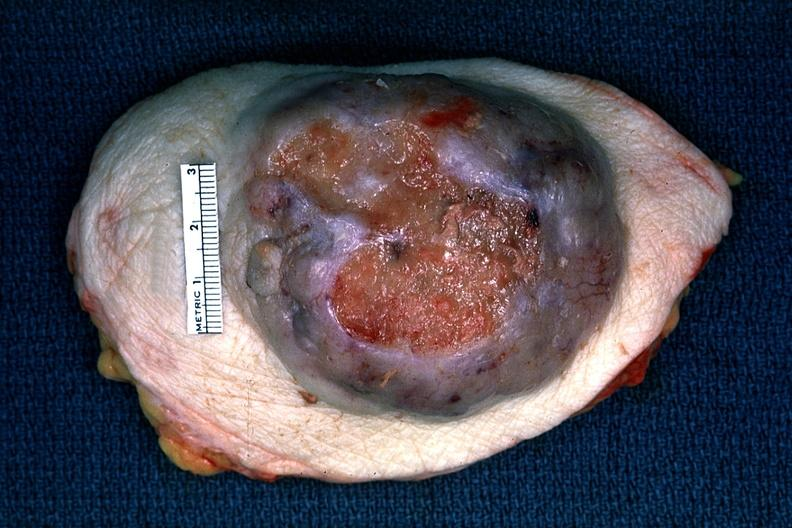s abdomen present?
Answer the question using a single word or phrase. No 